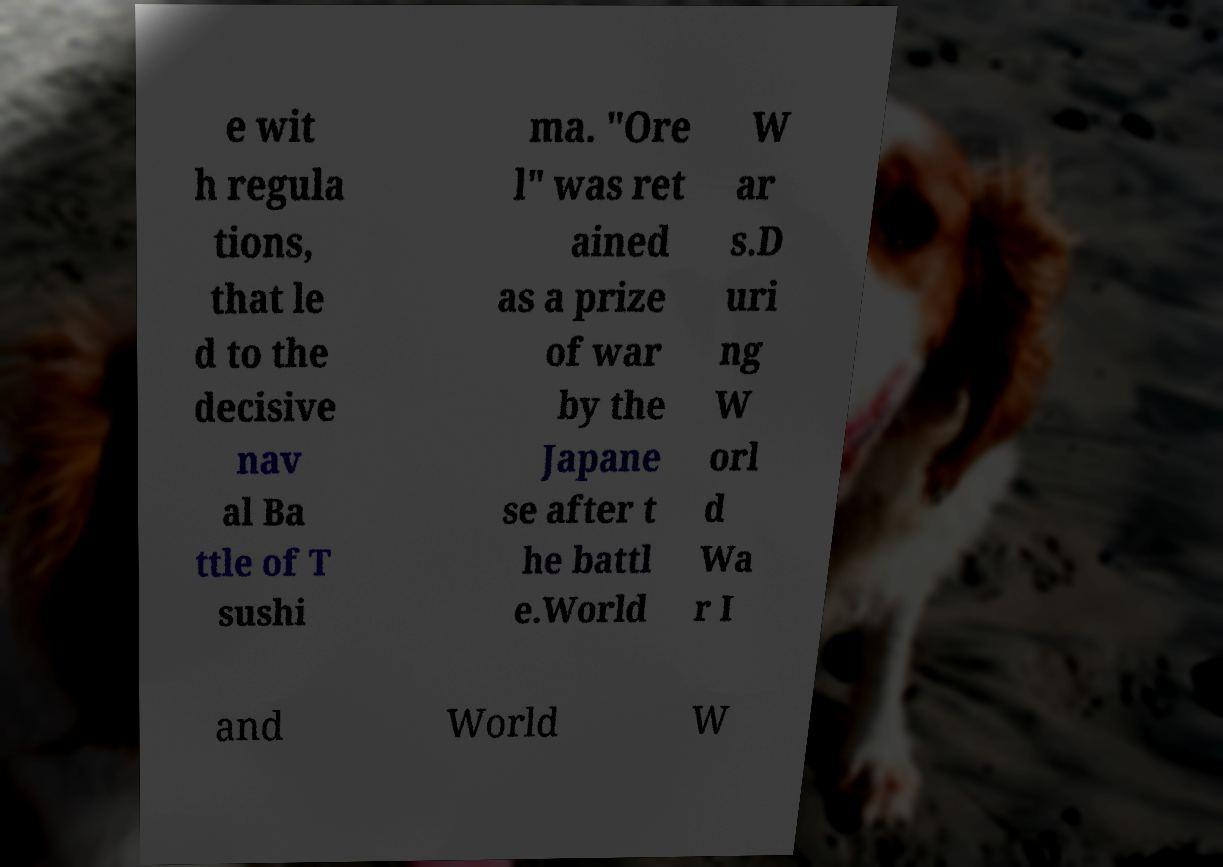What messages or text are displayed in this image? I need them in a readable, typed format. e wit h regula tions, that le d to the decisive nav al Ba ttle of T sushi ma. "Ore l" was ret ained as a prize of war by the Japane se after t he battl e.World W ar s.D uri ng W orl d Wa r I and World W 